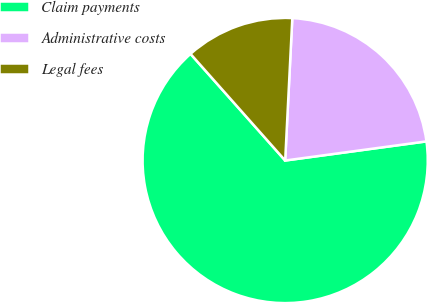<chart> <loc_0><loc_0><loc_500><loc_500><pie_chart><fcel>Claim payments<fcel>Administrative costs<fcel>Legal fees<nl><fcel>65.59%<fcel>22.06%<fcel>12.35%<nl></chart> 